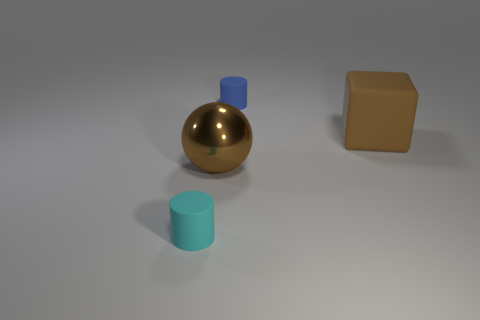There is a thing that is both behind the cyan object and in front of the big block; what color is it?
Your answer should be very brief. Brown. Is the number of large shiny objects greater than the number of tiny objects?
Keep it short and to the point. No. How many things are either big brown spheres or tiny rubber things in front of the big rubber block?
Provide a succinct answer. 2. Do the cyan rubber cylinder and the blue rubber cylinder have the same size?
Ensure brevity in your answer.  Yes. Are there any tiny cyan things to the right of the large brown block?
Your answer should be compact. No. There is a rubber object that is both to the left of the brown rubber cube and in front of the small blue rubber thing; what is its size?
Make the answer very short. Small. How many objects are either tiny cyan things or large brown blocks?
Provide a short and direct response. 2. Do the brown shiny ball and the rubber cylinder behind the cyan cylinder have the same size?
Keep it short and to the point. No. There is a cylinder that is in front of the small cylinder that is behind the tiny thing that is in front of the big shiny thing; how big is it?
Give a very brief answer. Small. Are there any brown cylinders?
Ensure brevity in your answer.  No. 